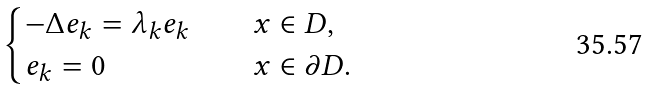<formula> <loc_0><loc_0><loc_500><loc_500>\begin{cases} - \Delta e _ { k } = \lambda _ { k } e _ { k } & \quad x \in D , \\ e _ { k } = 0 & \quad x \in \partial D . \end{cases}</formula> 